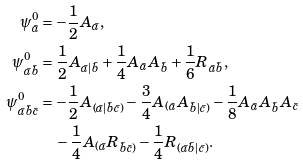Convert formula to latex. <formula><loc_0><loc_0><loc_500><loc_500>\psi ^ { 0 } _ { \bar { a } } & = - \frac { 1 } { 2 } A _ { \bar { a } } , \\ \psi ^ { 0 } _ { \bar { a } \bar { b } } & = \frac { 1 } { 2 } A _ { \bar { a } | \bar { b } } + \frac { 1 } { 4 } A _ { \bar { a } } A _ { \bar { b } } + \frac { 1 } { 6 } R _ { \bar { a } \bar { b } } , \\ \psi ^ { 0 } _ { \bar { a } \bar { b } \bar { c } } & = - \frac { 1 } { 2 } A _ { ( \bar { a } | \bar { b } \bar { c } ) } - \frac { 3 } { 4 } A _ { ( \bar { a } } A _ { \bar { b } | \bar { c } ) } - \frac { 1 } { 8 } A _ { \bar { a } } A _ { \bar { b } } A _ { \bar { c } } \\ & \quad - \frac { 1 } { 4 } A _ { ( \bar { a } } R _ { \bar { b } \bar { c } ) } - \frac { 1 } { 4 } R _ { ( \bar { a } \bar { b } | \bar { c } ) } .</formula> 